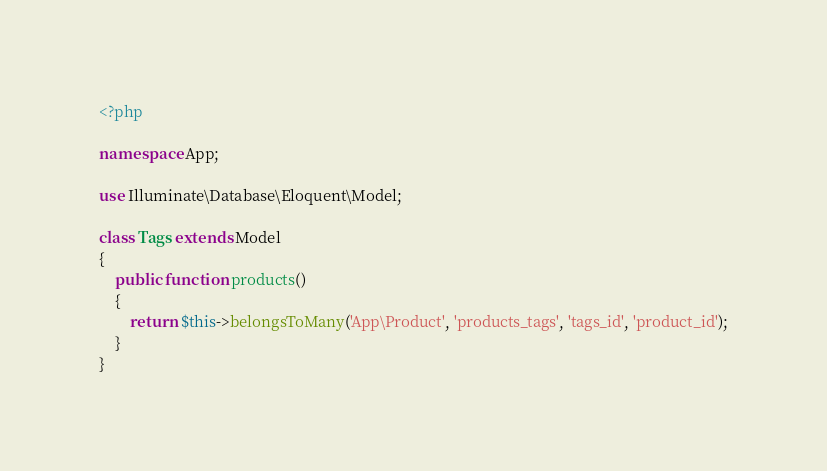<code> <loc_0><loc_0><loc_500><loc_500><_PHP_><?php

namespace App;

use Illuminate\Database\Eloquent\Model;

class Tags extends Model
{
    public function products()
    {
    	return $this->belongsToMany('App\Product', 'products_tags', 'tags_id', 'product_id');
    }
}</code> 